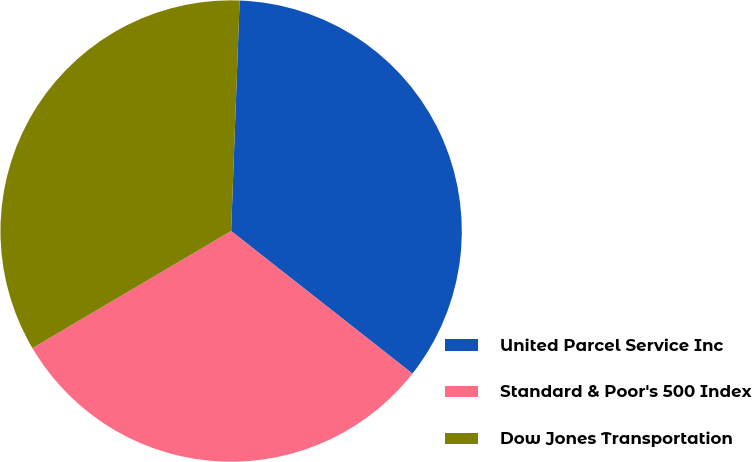Convert chart. <chart><loc_0><loc_0><loc_500><loc_500><pie_chart><fcel>United Parcel Service Inc<fcel>Standard & Poor's 500 Index<fcel>Dow Jones Transportation<nl><fcel>35.02%<fcel>30.92%<fcel>34.06%<nl></chart> 